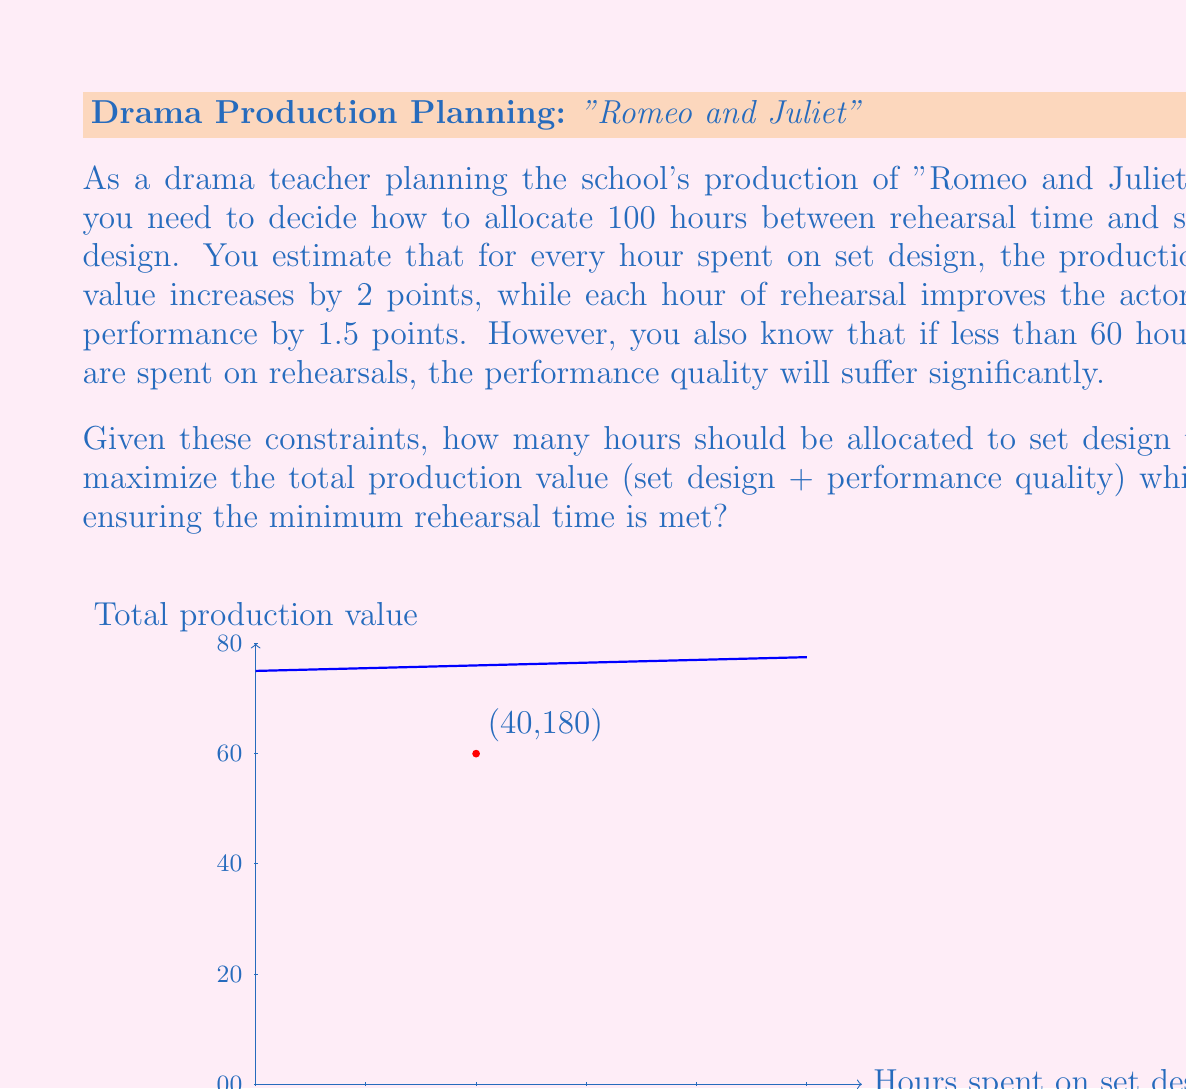Provide a solution to this math problem. Let's approach this step-by-step:

1) Let $x$ be the number of hours spent on set design. Then, $(100-x)$ will be the hours spent on rehearsal.

2) The production value can be expressed as a function:
   $f(x) = 2x + 1.5(100-x)$
   Where $2x$ represents the value from set design and $1.5(100-x)$ represents the value from rehearsals.

3) We need to maximize this function, but we have a constraint: rehearsal time must be at least 60 hours. This means:
   $100 - x \geq 60$
   $x \leq 40$

4) Let's simplify our function:
   $f(x) = 2x + 150 - 1.5x = 0.5x + 150$

5) This is a linear function with a positive slope, which means it will reach its maximum value at the highest possible value of $x$ that satisfies our constraint.

6) The highest possible value for $x$ is 40 (from step 3).

7) Therefore, the optimal allocation is 40 hours for set design and 60 hours for rehearsal.

8) The maximum production value is:
   $f(40) = 0.5(40) + 150 = 170$

We can verify that this indeed gives us the maximum value while meeting the rehearsal time requirement.
Answer: 40 hours for set design, achieving a total production value of 180 points. 